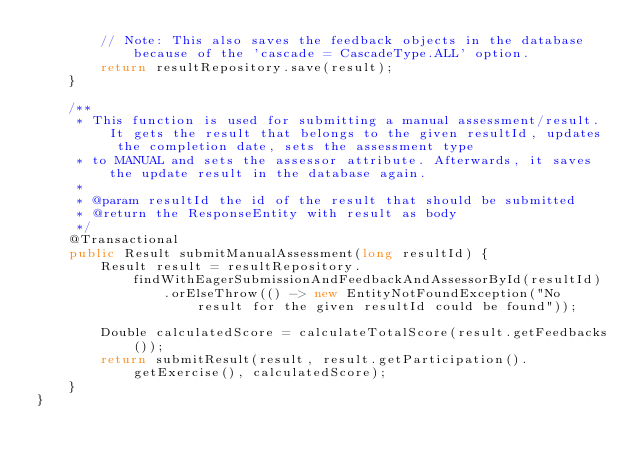<code> <loc_0><loc_0><loc_500><loc_500><_Java_>        // Note: This also saves the feedback objects in the database because of the 'cascade = CascadeType.ALL' option.
        return resultRepository.save(result);
    }

    /**
     * This function is used for submitting a manual assessment/result. It gets the result that belongs to the given resultId, updates the completion date, sets the assessment type
     * to MANUAL and sets the assessor attribute. Afterwards, it saves the update result in the database again.
     *
     * @param resultId the id of the result that should be submitted
     * @return the ResponseEntity with result as body
     */
    @Transactional
    public Result submitManualAssessment(long resultId) {
        Result result = resultRepository.findWithEagerSubmissionAndFeedbackAndAssessorById(resultId)
                .orElseThrow(() -> new EntityNotFoundException("No result for the given resultId could be found"));

        Double calculatedScore = calculateTotalScore(result.getFeedbacks());
        return submitResult(result, result.getParticipation().getExercise(), calculatedScore);
    }
}
</code> 